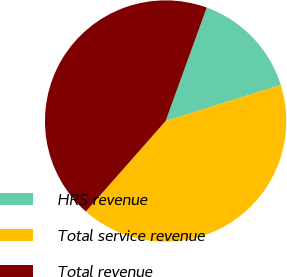Convert chart to OTSL. <chart><loc_0><loc_0><loc_500><loc_500><pie_chart><fcel>HRS revenue<fcel>Total service revenue<fcel>Total revenue<nl><fcel>14.65%<fcel>41.31%<fcel>44.04%<nl></chart> 